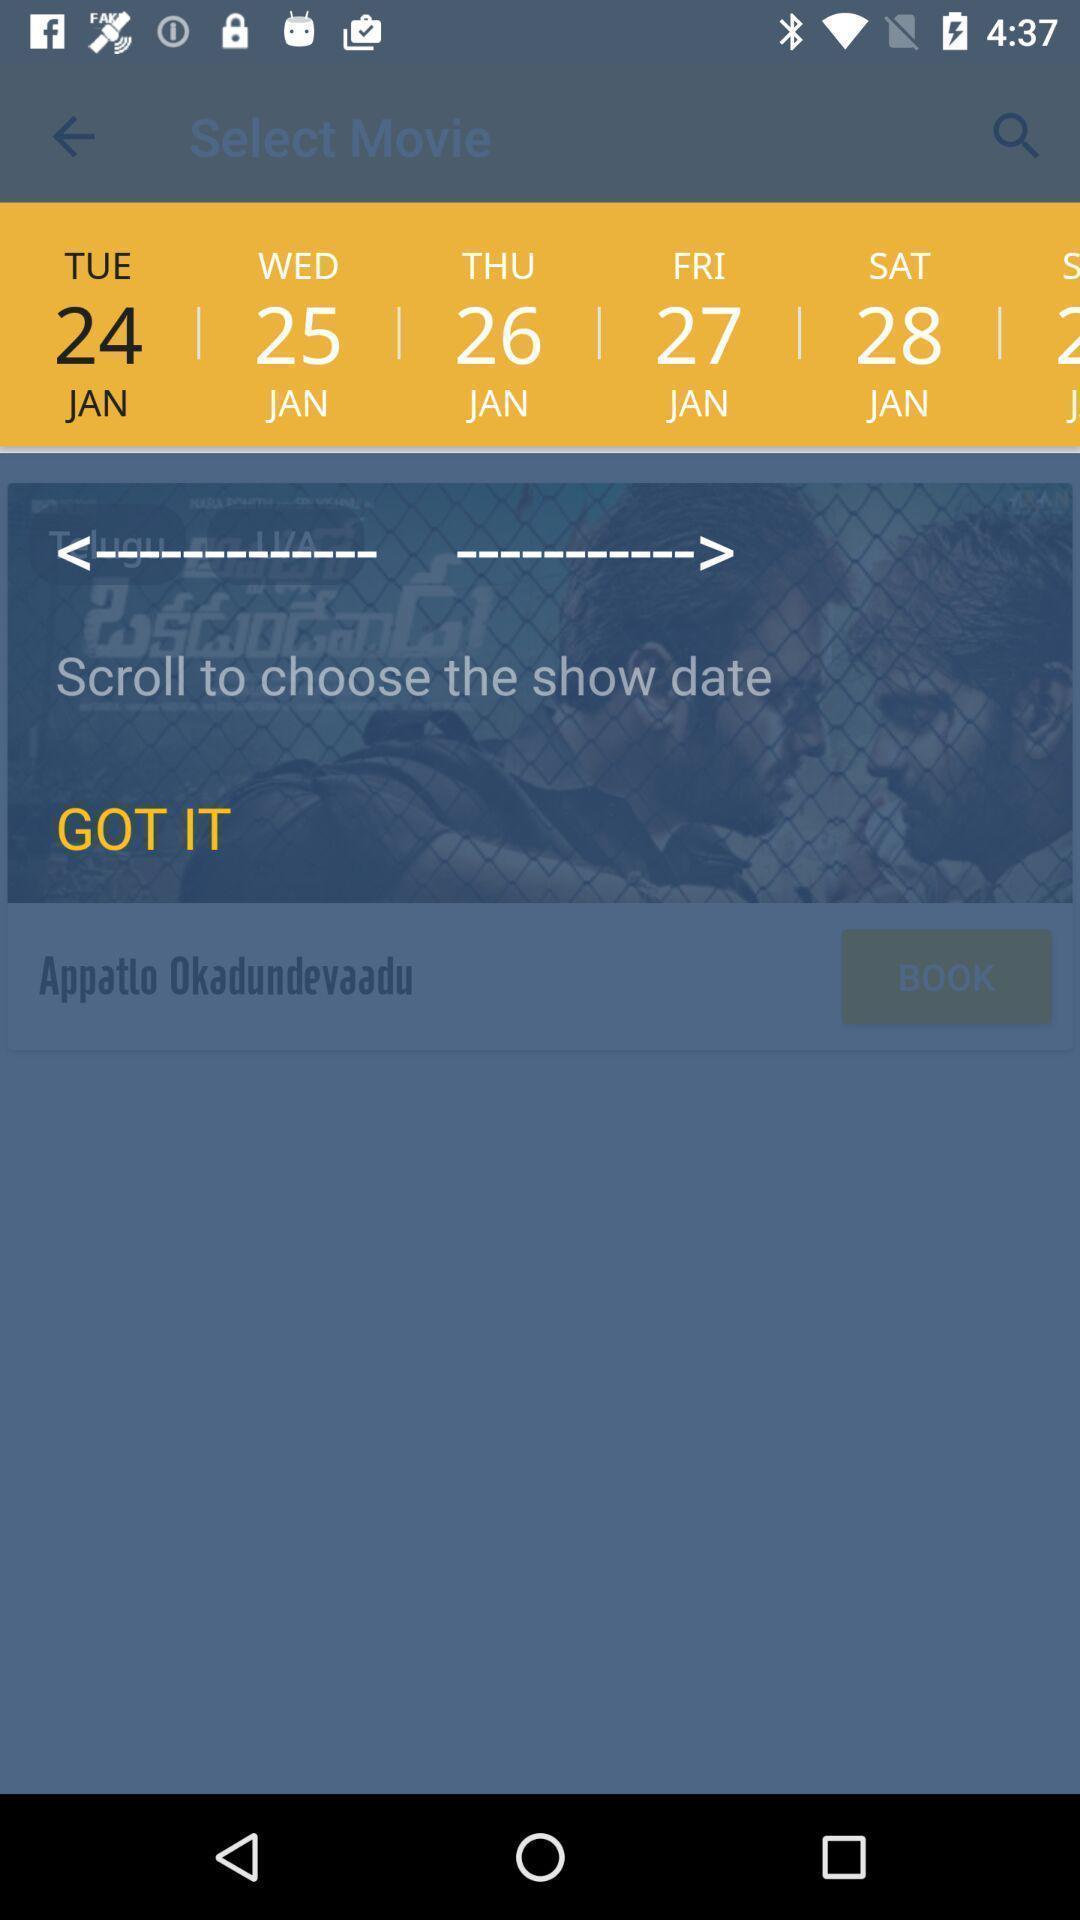Summarize the information in this screenshot. Push up page displaying instruction to choose a date. 